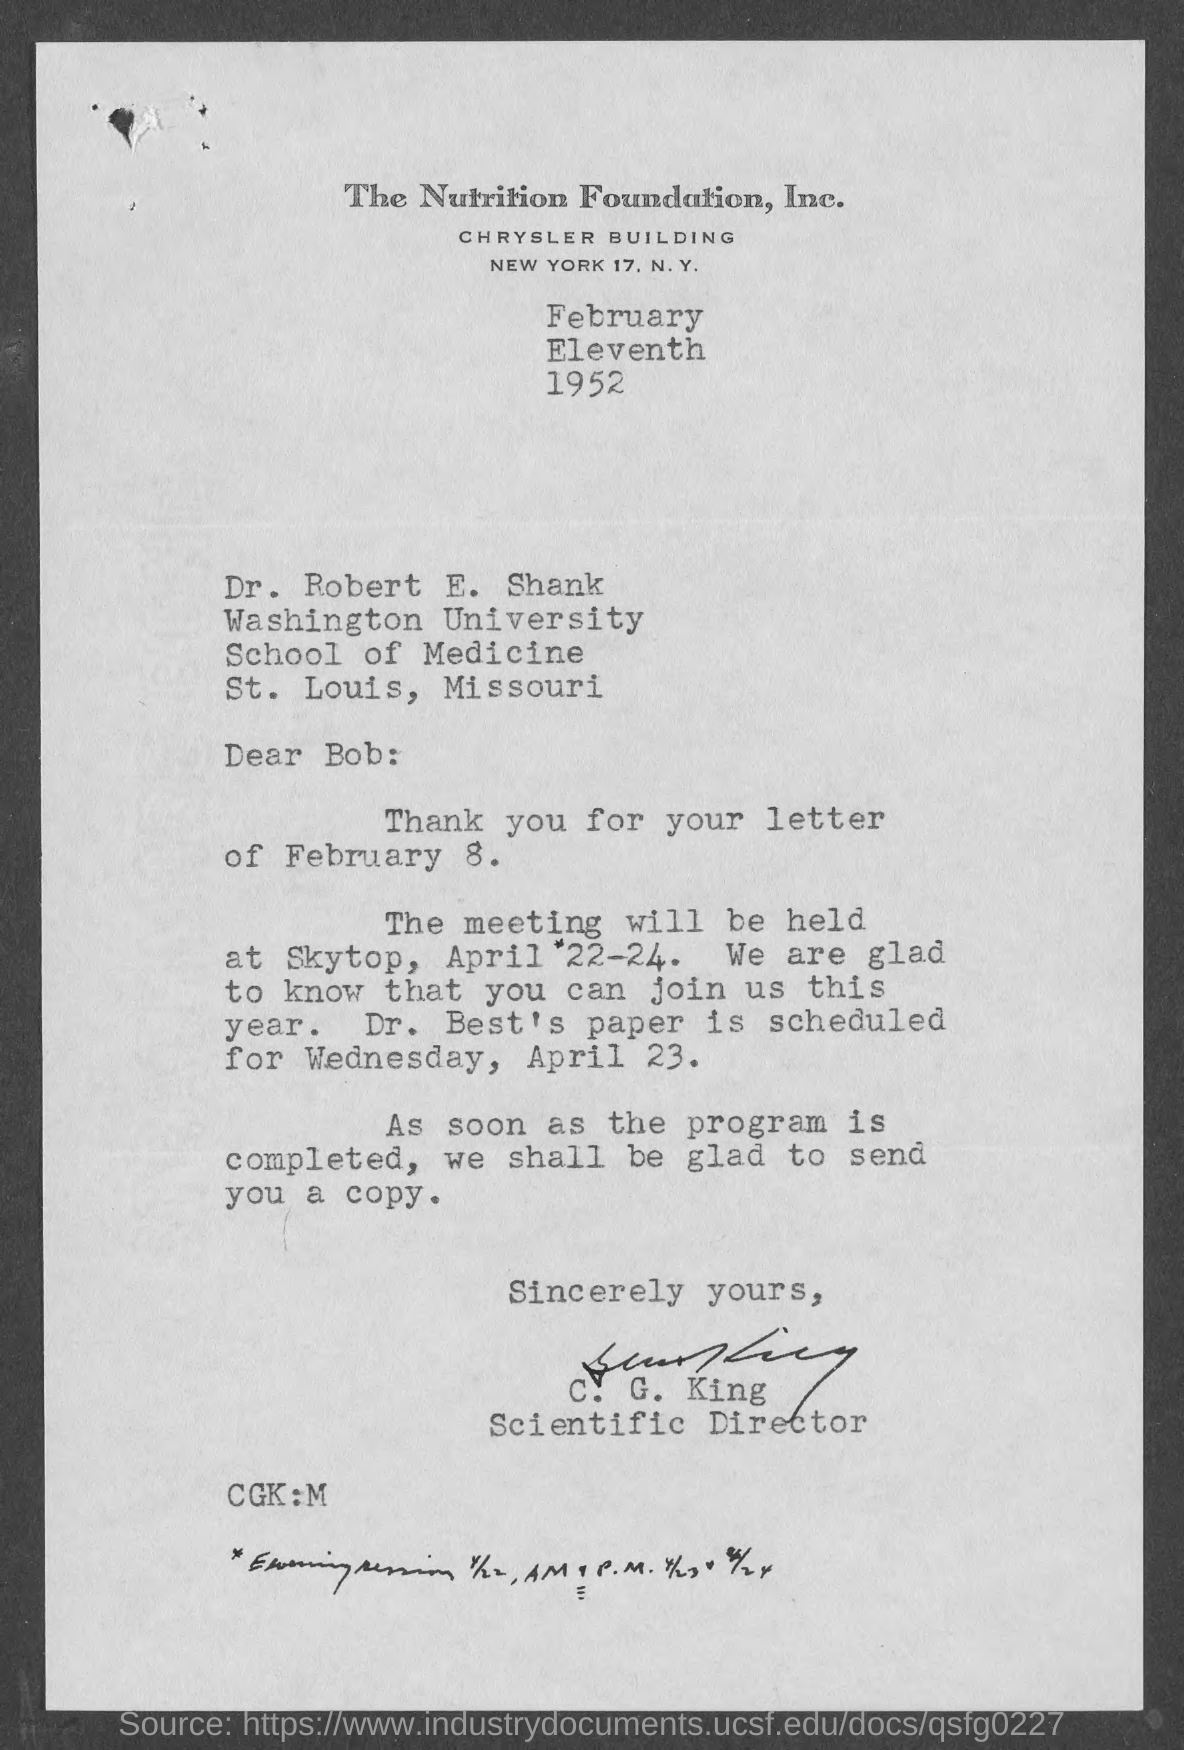Which foundation is mentioned at the top of the page?
Your response must be concise. The Nutrition Foundation, Inc. To whom is the letter addressed?
Provide a short and direct response. Dr. Robert E. Shank. When will the meeting be held?
Your answer should be very brief. April 22-24. Where will the meeting be held?
Keep it short and to the point. Skytop. When is Dr. Best's paper scheduled?
Ensure brevity in your answer.  Wednesday, April 23. Who has signed the letter?
Give a very brief answer. C. G. King. What is C. G. King's title?
Make the answer very short. Scientific Director. 